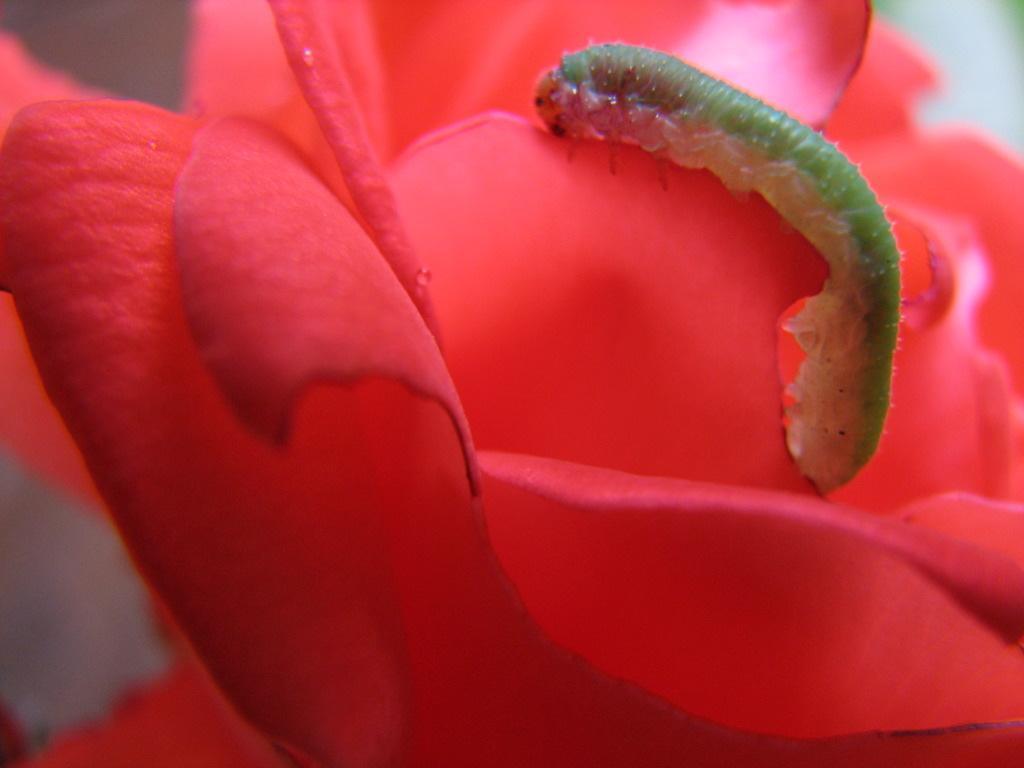Please provide a concise description of this image. This is a zoomed in picture. On the right there is a green color caterpillar on the petal of a red color flower. The background of the image is blurry. 